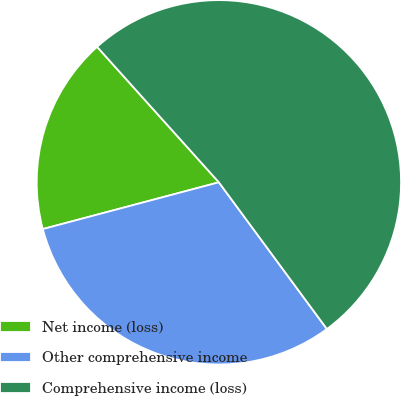Convert chart to OTSL. <chart><loc_0><loc_0><loc_500><loc_500><pie_chart><fcel>Net income (loss)<fcel>Other comprehensive income<fcel>Comprehensive income (loss)<nl><fcel>17.48%<fcel>30.97%<fcel>51.55%<nl></chart> 